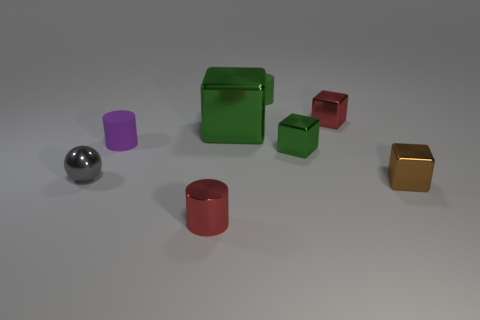The green metal thing that is the same size as the red cylinder is what shape?
Provide a succinct answer. Cube. There is a block that is in front of the gray object; what is its color?
Ensure brevity in your answer.  Brown. There is a green metal cube that is on the left side of the small green rubber cylinder; are there any large metallic things that are on the right side of it?
Provide a succinct answer. No. What number of objects are either tiny objects to the right of the large metal block or small purple matte cylinders?
Give a very brief answer. 5. What material is the small green thing that is behind the red thing that is right of the red cylinder?
Offer a very short reply. Rubber. Are there the same number of green matte cylinders behind the tiny green rubber cylinder and brown blocks that are to the right of the big metal cube?
Offer a terse response. No. What number of things are either red shiny things to the right of the green rubber thing or small metallic objects on the right side of the red shiny cylinder?
Offer a very short reply. 3. There is a small thing that is both behind the gray object and left of the green rubber cylinder; what is its material?
Give a very brief answer. Rubber. What is the size of the matte object to the left of the tiny cylinder in front of the tiny rubber cylinder that is in front of the big green block?
Offer a very short reply. Small. Is the number of tiny cylinders greater than the number of small green metal cubes?
Ensure brevity in your answer.  Yes. 